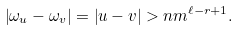Convert formula to latex. <formula><loc_0><loc_0><loc_500><loc_500>\left | \omega _ { u } - \omega _ { v } \right | = \left | u - v \right | > n m ^ { \ell - r + 1 } .</formula> 